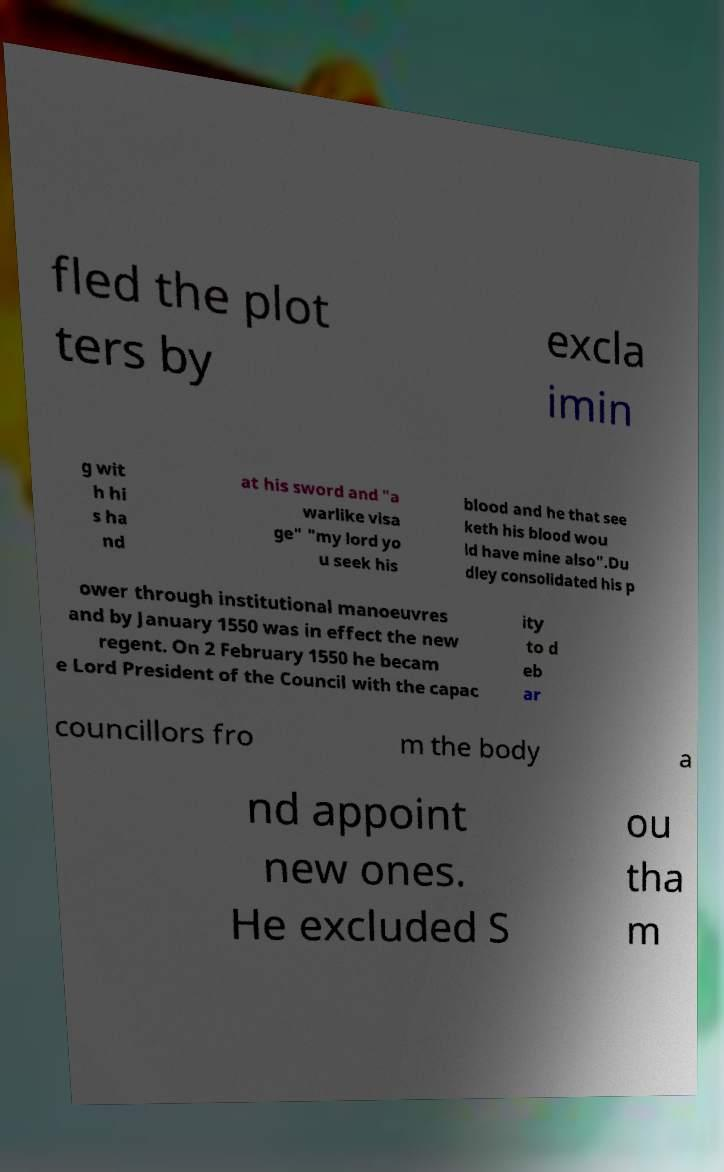There's text embedded in this image that I need extracted. Can you transcribe it verbatim? fled the plot ters by excla imin g wit h hi s ha nd at his sword and "a warlike visa ge" "my lord yo u seek his blood and he that see keth his blood wou ld have mine also".Du dley consolidated his p ower through institutional manoeuvres and by January 1550 was in effect the new regent. On 2 February 1550 he becam e Lord President of the Council with the capac ity to d eb ar councillors fro m the body a nd appoint new ones. He excluded S ou tha m 